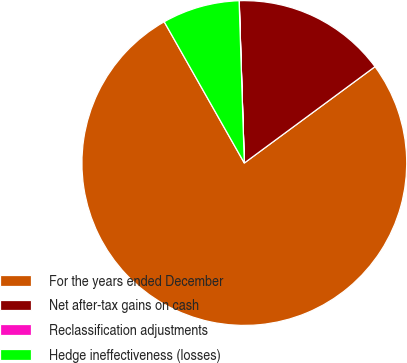<chart> <loc_0><loc_0><loc_500><loc_500><pie_chart><fcel>For the years ended December<fcel>Net after-tax gains on cash<fcel>Reclassification adjustments<fcel>Hedge ineffectiveness (losses)<nl><fcel>76.91%<fcel>15.39%<fcel>0.01%<fcel>7.7%<nl></chart> 